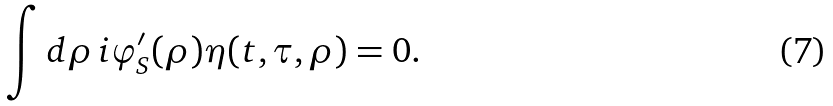<formula> <loc_0><loc_0><loc_500><loc_500>\int d \rho \, i \varphi ^ { \prime } _ { S } ( \rho ) \eta ( t , \tau , \rho ) = 0 .</formula> 